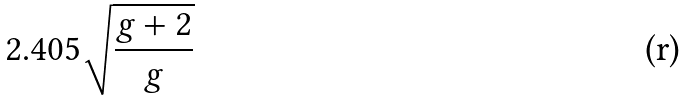Convert formula to latex. <formula><loc_0><loc_0><loc_500><loc_500>2 . 4 0 5 \sqrt { \frac { g + 2 } { g } }</formula> 